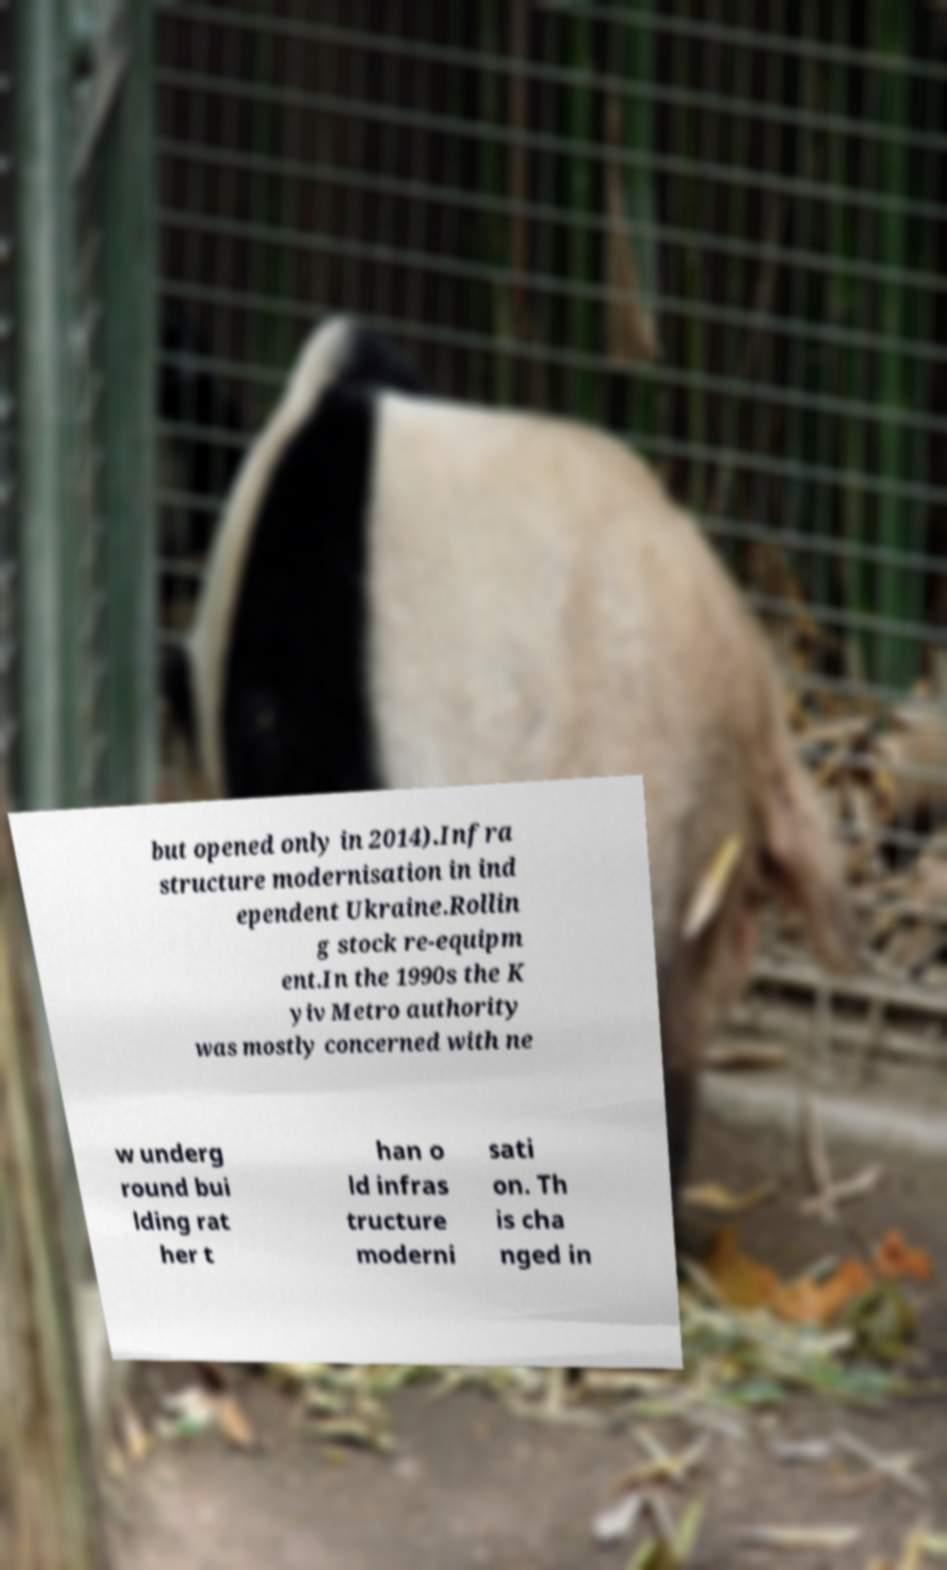Could you extract and type out the text from this image? but opened only in 2014).Infra structure modernisation in ind ependent Ukraine.Rollin g stock re-equipm ent.In the 1990s the K yiv Metro authority was mostly concerned with ne w underg round bui lding rat her t han o ld infras tructure moderni sati on. Th is cha nged in 